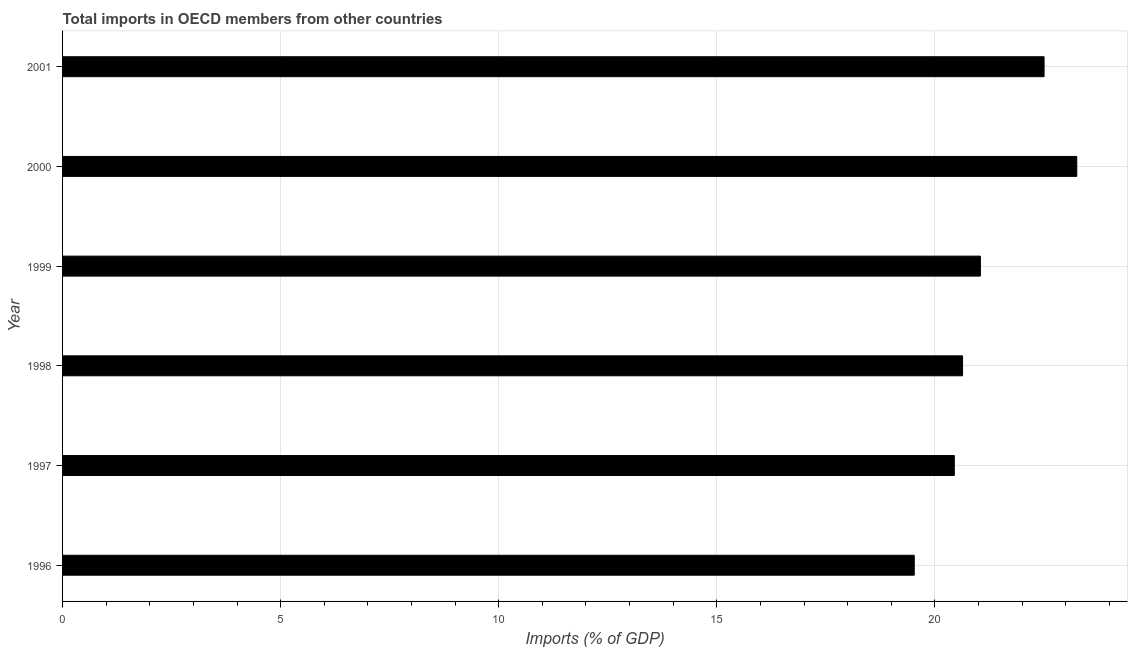Does the graph contain grids?
Make the answer very short. Yes. What is the title of the graph?
Make the answer very short. Total imports in OECD members from other countries. What is the label or title of the X-axis?
Offer a very short reply. Imports (% of GDP). What is the total imports in 2001?
Provide a short and direct response. 22.5. Across all years, what is the maximum total imports?
Offer a terse response. 23.25. Across all years, what is the minimum total imports?
Make the answer very short. 19.53. In which year was the total imports maximum?
Offer a very short reply. 2000. In which year was the total imports minimum?
Make the answer very short. 1996. What is the sum of the total imports?
Provide a short and direct response. 127.41. What is the difference between the total imports in 1998 and 2000?
Ensure brevity in your answer.  -2.62. What is the average total imports per year?
Keep it short and to the point. 21.23. What is the median total imports?
Your answer should be very brief. 20.84. In how many years, is the total imports greater than 11 %?
Give a very brief answer. 6. Do a majority of the years between 1998 and 1997 (inclusive) have total imports greater than 16 %?
Provide a succinct answer. No. What is the ratio of the total imports in 1996 to that in 1998?
Ensure brevity in your answer.  0.95. Is the total imports in 1996 less than that in 1998?
Give a very brief answer. Yes. Is the difference between the total imports in 1997 and 2000 greater than the difference between any two years?
Give a very brief answer. No. What is the difference between the highest and the second highest total imports?
Give a very brief answer. 0.75. Is the sum of the total imports in 1996 and 2000 greater than the maximum total imports across all years?
Make the answer very short. Yes. What is the difference between the highest and the lowest total imports?
Provide a short and direct response. 3.73. How many years are there in the graph?
Provide a short and direct response. 6. What is the Imports (% of GDP) of 1996?
Make the answer very short. 19.53. What is the Imports (% of GDP) in 1997?
Offer a terse response. 20.45. What is the Imports (% of GDP) in 1998?
Your response must be concise. 20.63. What is the Imports (% of GDP) in 1999?
Give a very brief answer. 21.04. What is the Imports (% of GDP) in 2000?
Your answer should be very brief. 23.25. What is the Imports (% of GDP) of 2001?
Ensure brevity in your answer.  22.5. What is the difference between the Imports (% of GDP) in 1996 and 1997?
Provide a short and direct response. -0.92. What is the difference between the Imports (% of GDP) in 1996 and 1998?
Provide a succinct answer. -1.11. What is the difference between the Imports (% of GDP) in 1996 and 1999?
Offer a very short reply. -1.52. What is the difference between the Imports (% of GDP) in 1996 and 2000?
Your answer should be compact. -3.73. What is the difference between the Imports (% of GDP) in 1996 and 2001?
Offer a very short reply. -2.98. What is the difference between the Imports (% of GDP) in 1997 and 1998?
Your answer should be compact. -0.19. What is the difference between the Imports (% of GDP) in 1997 and 1999?
Ensure brevity in your answer.  -0.6. What is the difference between the Imports (% of GDP) in 1997 and 2000?
Provide a succinct answer. -2.81. What is the difference between the Imports (% of GDP) in 1997 and 2001?
Make the answer very short. -2.06. What is the difference between the Imports (% of GDP) in 1998 and 1999?
Your response must be concise. -0.41. What is the difference between the Imports (% of GDP) in 1998 and 2000?
Make the answer very short. -2.62. What is the difference between the Imports (% of GDP) in 1998 and 2001?
Give a very brief answer. -1.87. What is the difference between the Imports (% of GDP) in 1999 and 2000?
Provide a succinct answer. -2.21. What is the difference between the Imports (% of GDP) in 1999 and 2001?
Offer a very short reply. -1.46. What is the difference between the Imports (% of GDP) in 2000 and 2001?
Provide a short and direct response. 0.75. What is the ratio of the Imports (% of GDP) in 1996 to that in 1997?
Provide a short and direct response. 0.95. What is the ratio of the Imports (% of GDP) in 1996 to that in 1998?
Ensure brevity in your answer.  0.95. What is the ratio of the Imports (% of GDP) in 1996 to that in 1999?
Offer a terse response. 0.93. What is the ratio of the Imports (% of GDP) in 1996 to that in 2000?
Ensure brevity in your answer.  0.84. What is the ratio of the Imports (% of GDP) in 1996 to that in 2001?
Make the answer very short. 0.87. What is the ratio of the Imports (% of GDP) in 1997 to that in 1998?
Provide a succinct answer. 0.99. What is the ratio of the Imports (% of GDP) in 1997 to that in 1999?
Provide a short and direct response. 0.97. What is the ratio of the Imports (% of GDP) in 1997 to that in 2000?
Your response must be concise. 0.88. What is the ratio of the Imports (% of GDP) in 1997 to that in 2001?
Offer a terse response. 0.91. What is the ratio of the Imports (% of GDP) in 1998 to that in 1999?
Your answer should be compact. 0.98. What is the ratio of the Imports (% of GDP) in 1998 to that in 2000?
Your response must be concise. 0.89. What is the ratio of the Imports (% of GDP) in 1998 to that in 2001?
Offer a very short reply. 0.92. What is the ratio of the Imports (% of GDP) in 1999 to that in 2000?
Offer a terse response. 0.91. What is the ratio of the Imports (% of GDP) in 1999 to that in 2001?
Ensure brevity in your answer.  0.94. What is the ratio of the Imports (% of GDP) in 2000 to that in 2001?
Your answer should be very brief. 1.03. 